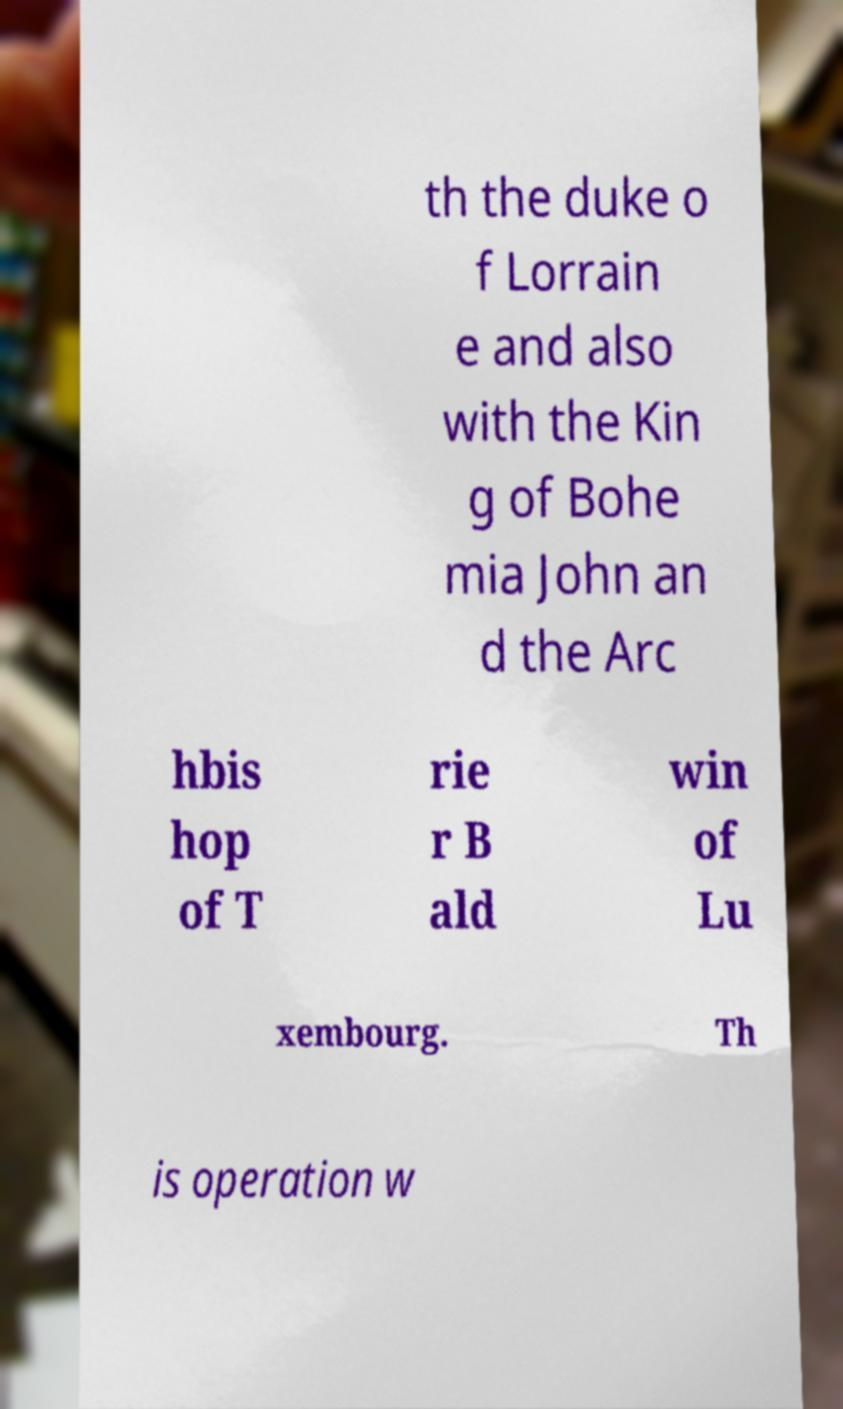Can you accurately transcribe the text from the provided image for me? th the duke o f Lorrain e and also with the Kin g of Bohe mia John an d the Arc hbis hop of T rie r B ald win of Lu xembourg. Th is operation w 